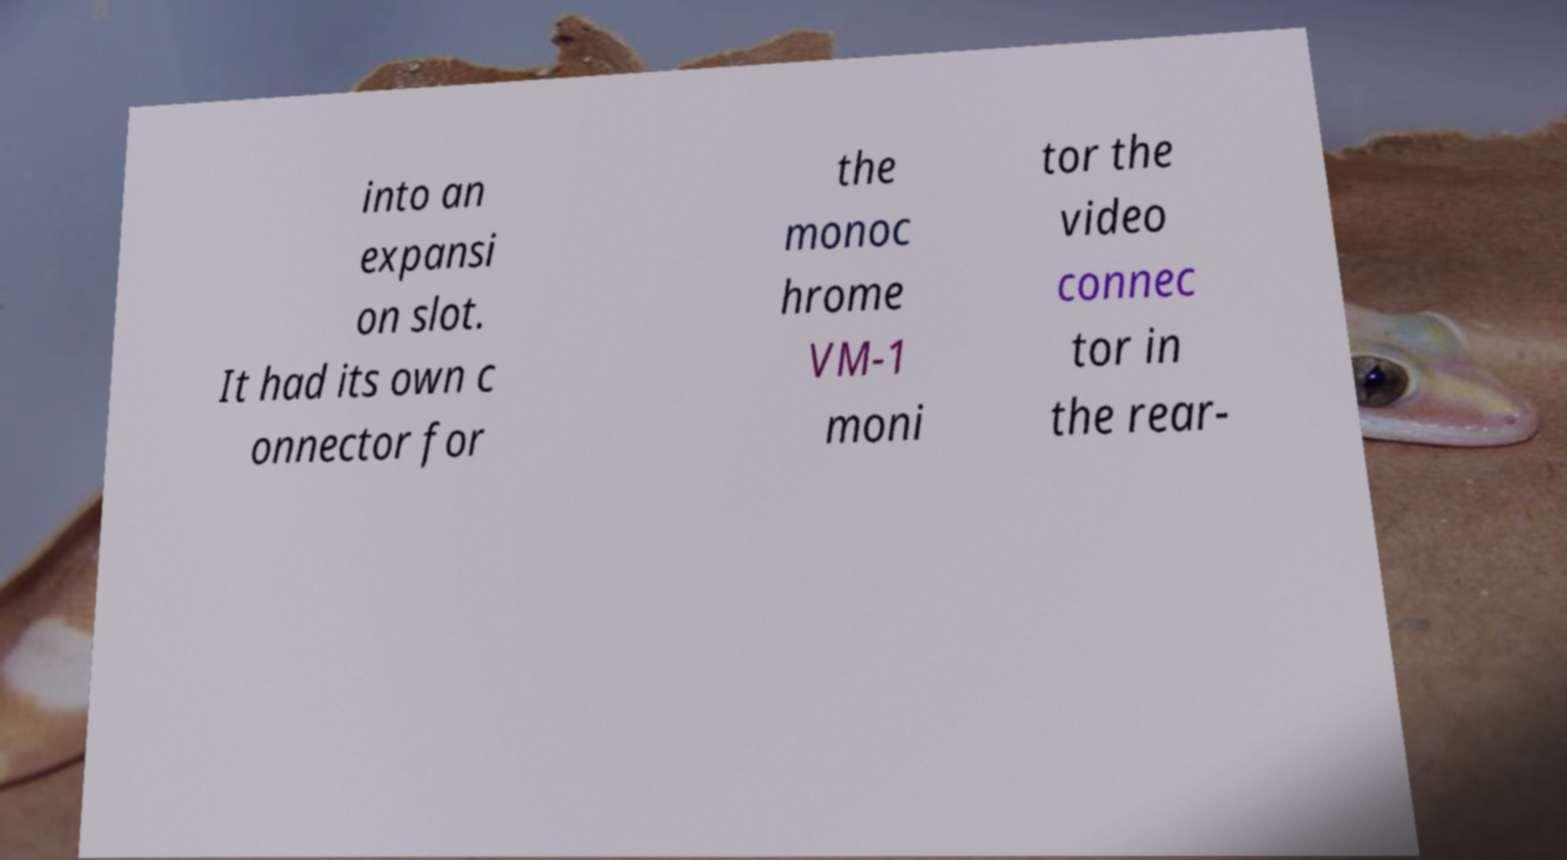I need the written content from this picture converted into text. Can you do that? into an expansi on slot. It had its own c onnector for the monoc hrome VM-1 moni tor the video connec tor in the rear- 